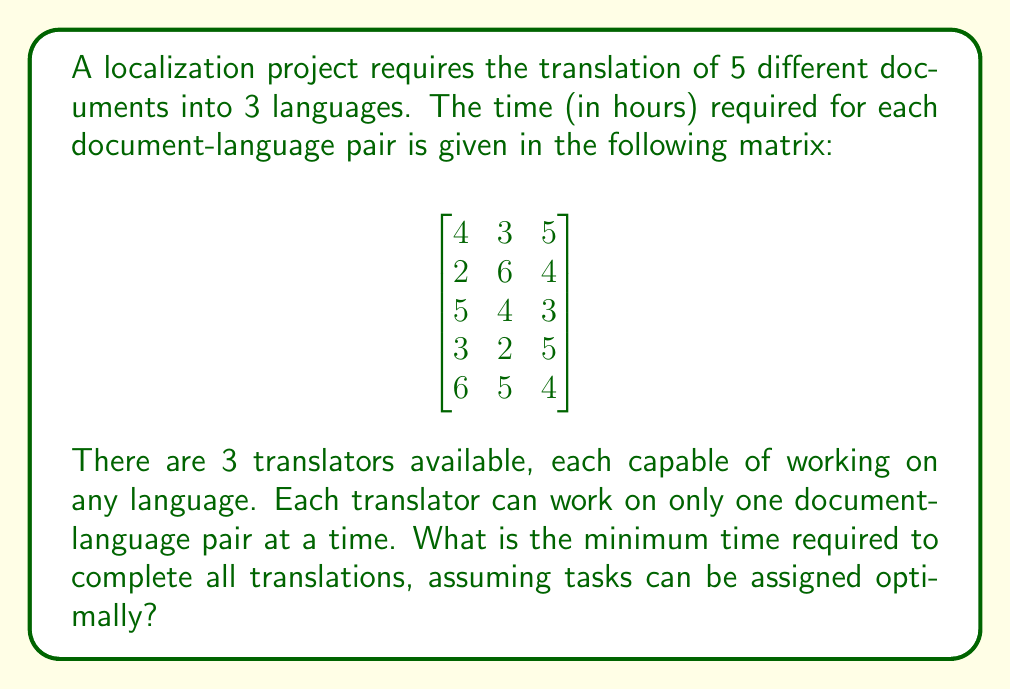Can you solve this math problem? This problem can be solved using the Hungarian algorithm for assignment problems. However, we need to adapt it for our scenario with more tasks than workers.

1. First, we need to create a square matrix by adding dummy rows:

$$
\begin{bmatrix}
4 & 3 & 5 \\
2 & 6 & 4 \\
5 & 4 & 3 \\
3 & 2 & 5 \\
6 & 5 & 4 \\
0 & 0 & 0 \\
0 & 0 & 0 \\
0 & 0 & 0 \\
0 & 0 & 0 \\
0 & 0 & 0
\end{bmatrix}
$$

2. Apply the Hungarian algorithm to this matrix:
   a) Subtract the minimum value in each row from all elements in that row.
   b) Subtract the minimum value in each column from all elements in that column.
   c) Draw lines through rows and columns to cover all zeros using the minimum number of lines.
   d) If the number of lines is less than the matrix size, create additional zeros and repeat step c.

3. The optimal assignment will be:
   - Translator 1: Document 2, Language 1 (2 hours)
   - Translator 2: Document 4, Language 2 (2 hours)
   - Translator 3: Document 3, Language 3 (3 hours)

4. After these assignments are complete, we repeat the process with the remaining tasks:
   - Translator 1: Document 1, Language 2 (3 hours)
   - Translator 2: Document 5, Language 3 (4 hours)
   - Translator 3: Document 3, Language 1 (5 hours)

5. For the final round:
   - Translator 1: Document 1, Language 3 (5 hours)
   - Translator 2: Document 5, Language 1 (6 hours)
   - Translator 3: Document 4, Language 3 (5 hours)

6. The total time for each round is the maximum time taken by any translator in that round:
   Round 1: 3 hours
   Round 2: 5 hours
   Round 3: 6 hours

7. The total minimum time is the sum of these round times: 3 + 5 + 6 = 14 hours.
Answer: The minimum time required to complete all translations is 14 hours. 